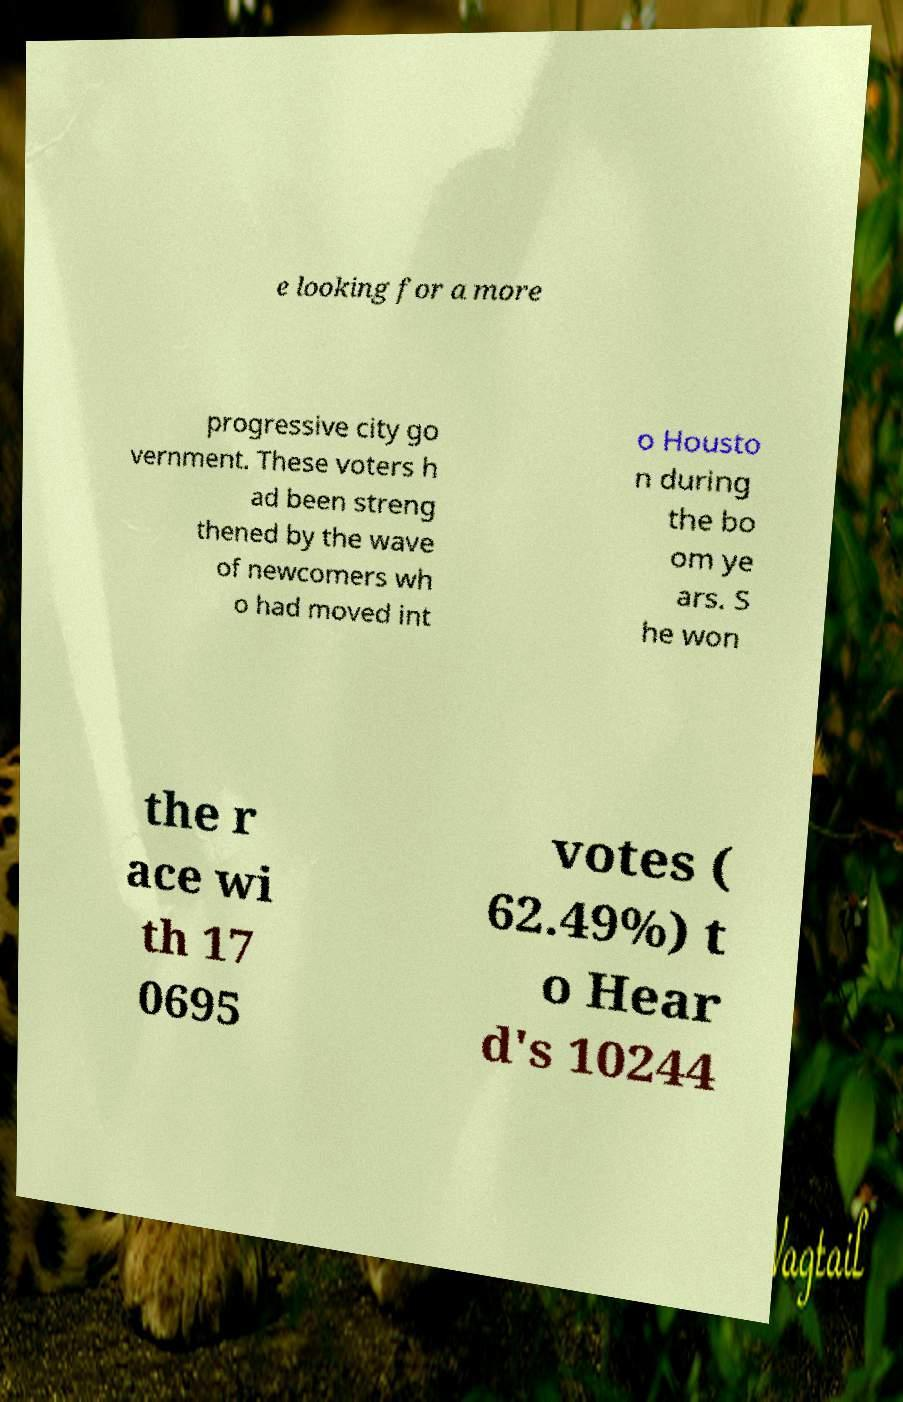For documentation purposes, I need the text within this image transcribed. Could you provide that? e looking for a more progressive city go vernment. These voters h ad been streng thened by the wave of newcomers wh o had moved int o Housto n during the bo om ye ars. S he won the r ace wi th 17 0695 votes ( 62.49%) t o Hear d's 10244 